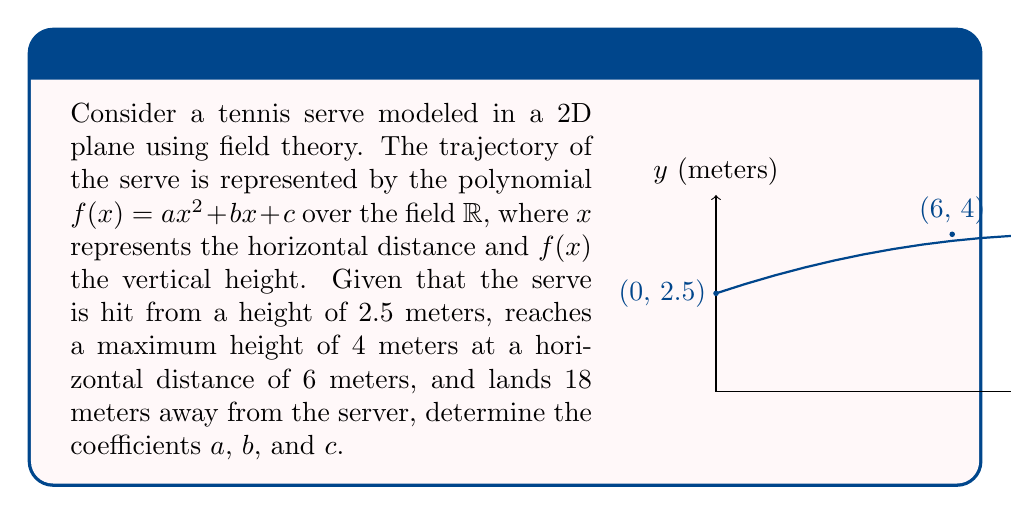Teach me how to tackle this problem. Let's approach this step-by-step using field theory over $\mathbb{R}$:

1) We have three conditions that define our polynomial $f(x) = ax^2 + bx + c$:

   i)   $f(0) = 2.5$  (initial height)
   ii)  $f(6) = 4$    (maximum height)
   iii) $f(18) = 0$   (landing point)

2) From condition (i): $f(0) = c = 2.5$

3) We can now set up two equations using (ii) and (iii):

   $36a + 6b + 2.5 = 4$     (from ii)
   $324a + 18b + 2.5 = 0$   (from iii)

4) Subtracting the first equation from the second:

   $288a + 12b = -4$
   $24a + b = -1/3$         (1)

5) The maximum point occurs when $f'(x) = 0$. We know this happens at $x = 6$:

   $f'(x) = 2ax + b$
   $2a(6) + b = 0$
   $12a + b = 0$            (2)

6) Subtracting (2) from (1):

   $12a = -1/3$
   $a = -1/36$

7) Substituting this back into (2):

   $12(-1/36) + b = 0$
   $b = 1/3$

8) We already know $c = 2.5$ from step 2.

Therefore, in the field $\mathbb{R}$, we have:

$a = -1/36$
$b = 1/3$
$c = 2.5$

The polynomial representing the trajectory is:

$f(x) = -\frac{1}{36}x^2 + \frac{1}{3}x + 2.5$
Answer: $a = -1/36$, $b = 1/3$, $c = 2.5$ 